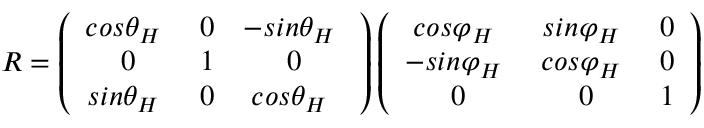<formula> <loc_0><loc_0><loc_500><loc_500>R = \left ( \begin{array} { c c c } { { { \cos } { \theta } _ { H } \ } } & { 0 } & { - { { \sin } { \theta } _ { H } \ } } \\ { 0 } & { 1 } & { 0 } \\ { { { \sin } { \theta } _ { H } \ } } & { 0 } & { { { \cos } { \theta } _ { H } \ } } \end{array} \right ) \left ( \begin{array} { c c c } { { { \cos } { \varphi } _ { H } \ } } & { { { \sin } { \varphi } _ { H } \ } } & { 0 } \\ { - { { \sin } { \varphi } _ { H } \ } } & { { { \cos } { \varphi } _ { H } \ } } & { 0 } \\ { 0 } & { 0 } & { 1 } \end{array} \right )</formula> 